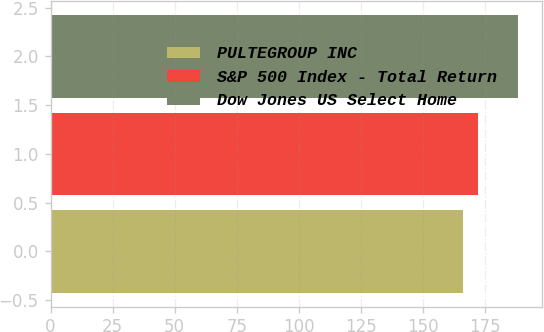Convert chart to OTSL. <chart><loc_0><loc_0><loc_500><loc_500><bar_chart><fcel>PULTEGROUP INC<fcel>S&P 500 Index - Total Return<fcel>Dow Jones US Select Home<nl><fcel>166.15<fcel>172.37<fcel>188.49<nl></chart> 